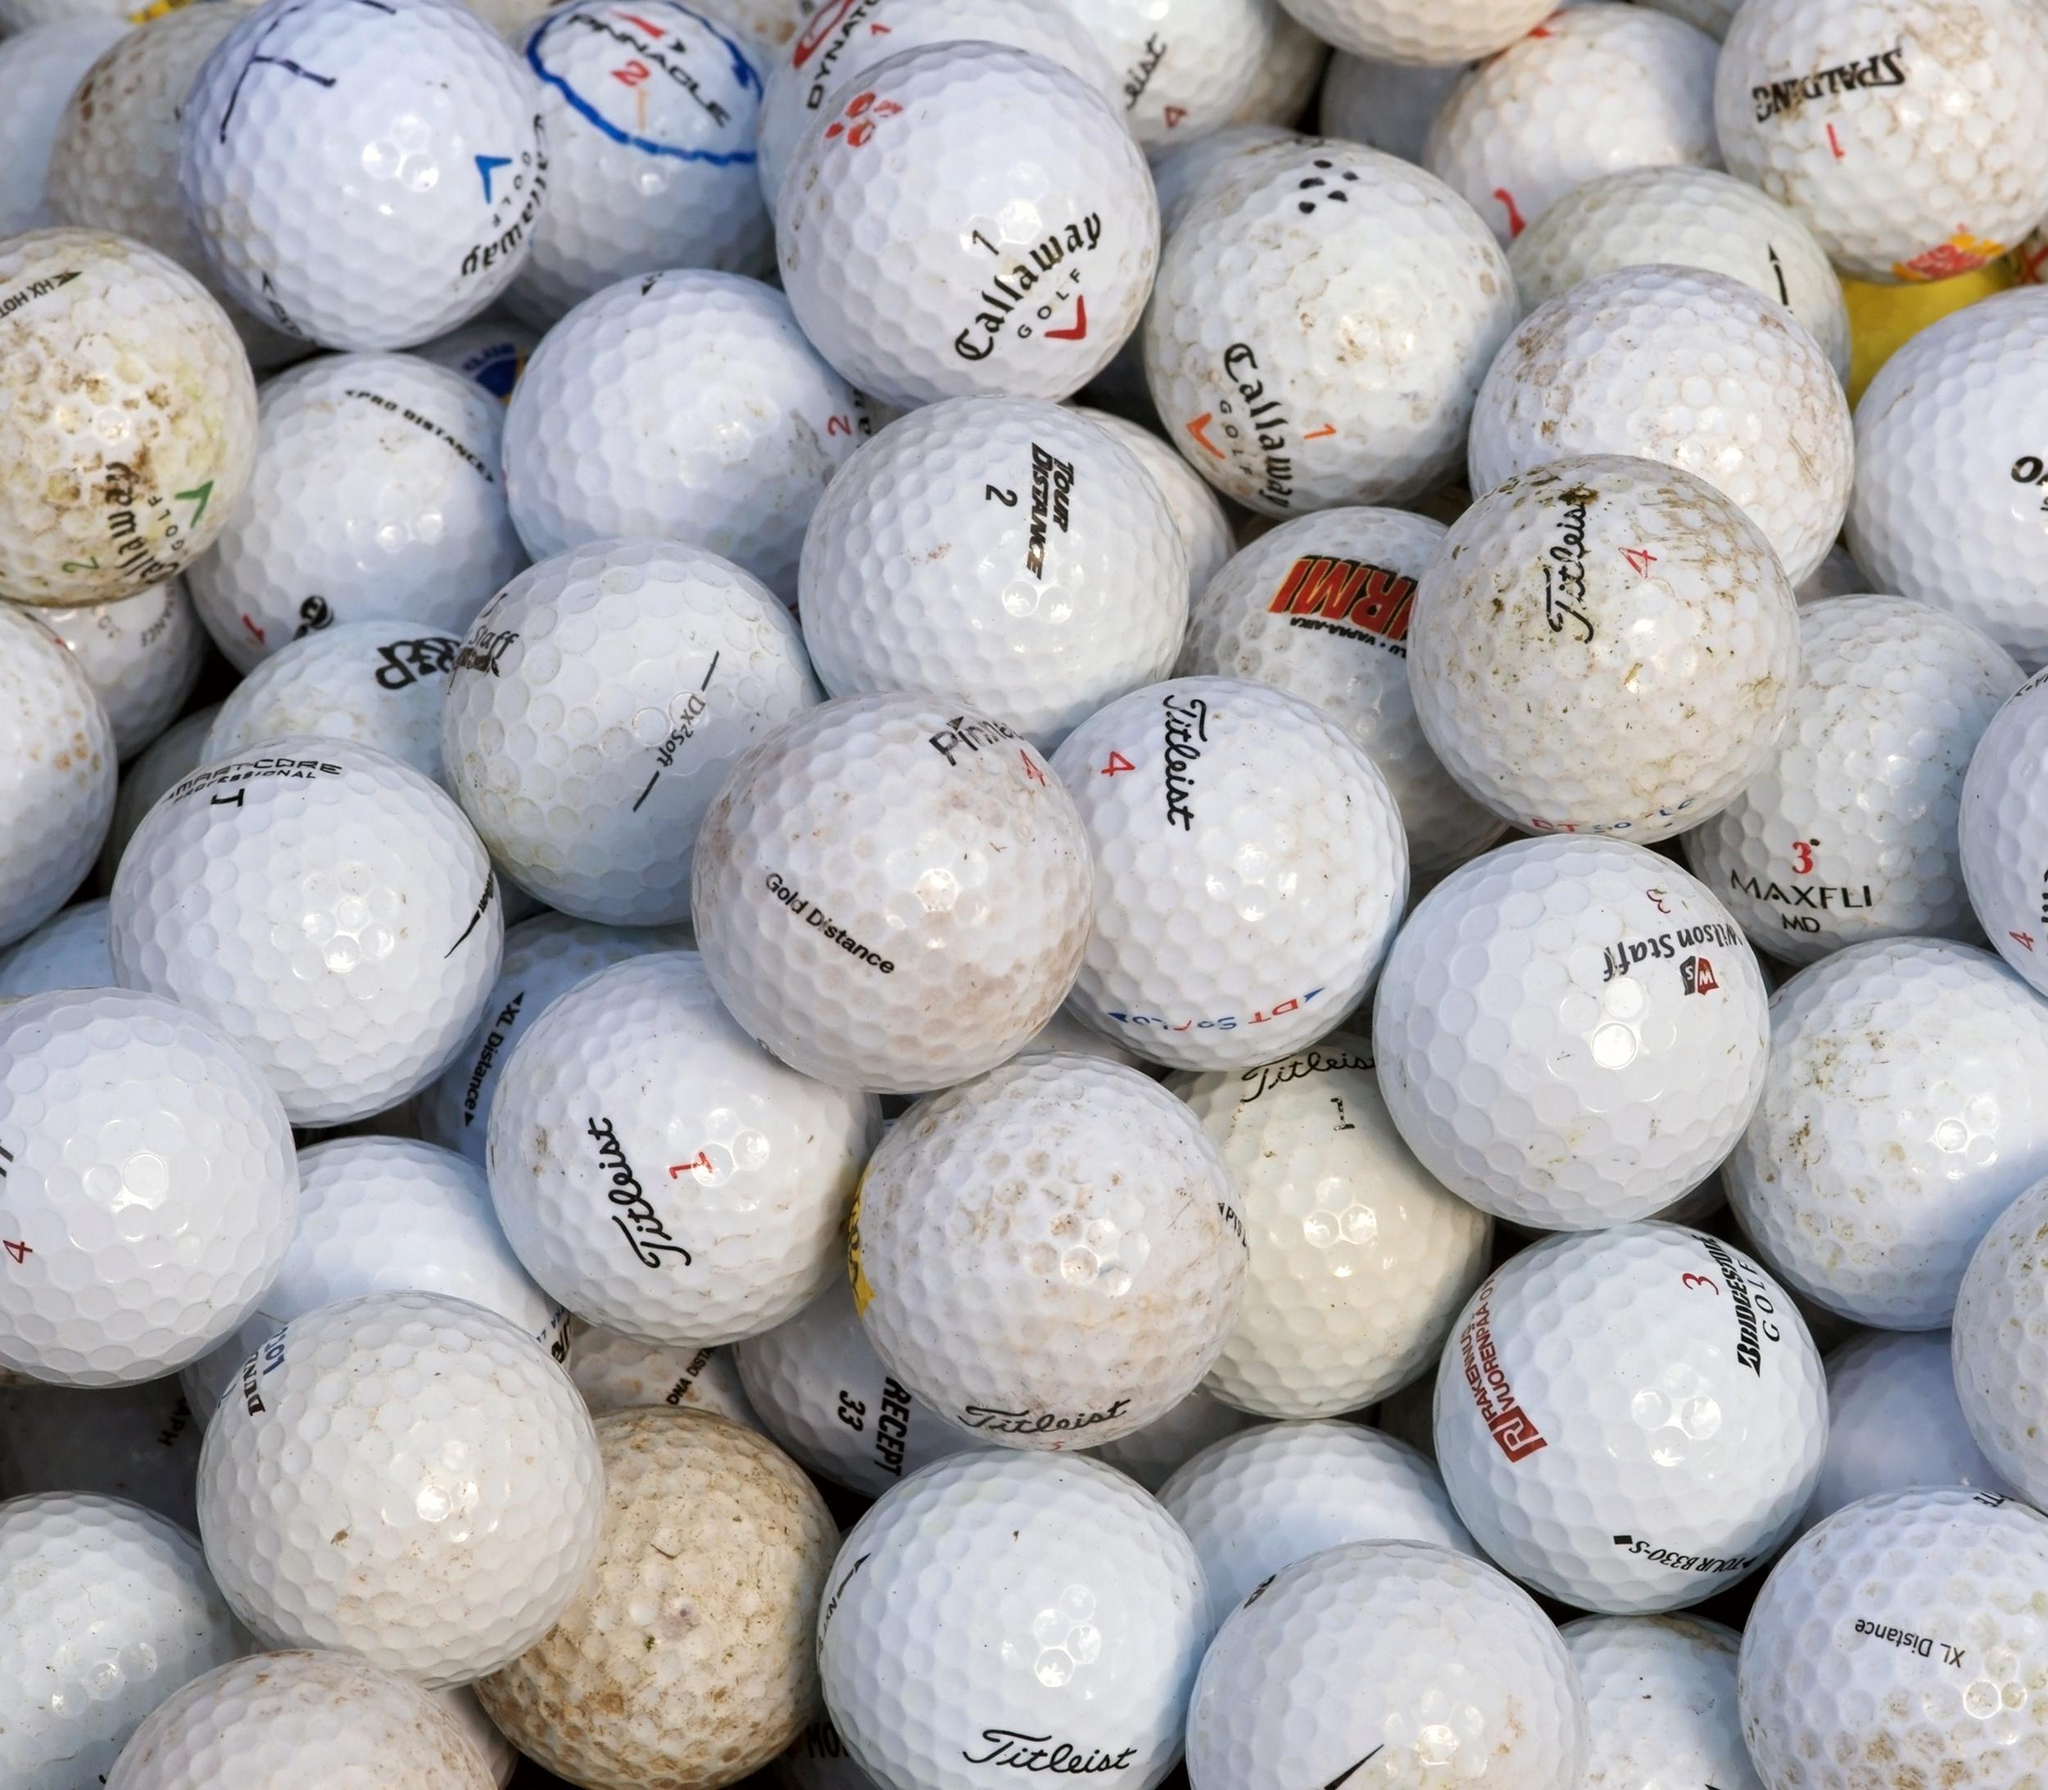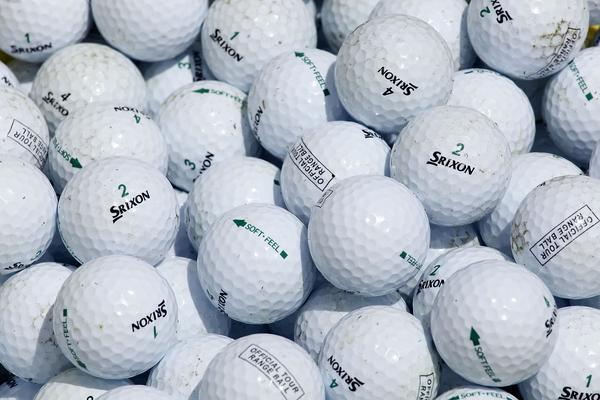The first image is the image on the left, the second image is the image on the right. For the images shown, is this caption "In one of the images, 12 golf balls are lined up neatly in a 3x4 or 4x3 pattern." true? Answer yes or no. No. The first image is the image on the left, the second image is the image on the right. Examine the images to the left and right. Is the description "In at least one image there is a total of 12 golf balls." accurate? Answer yes or no. No. 